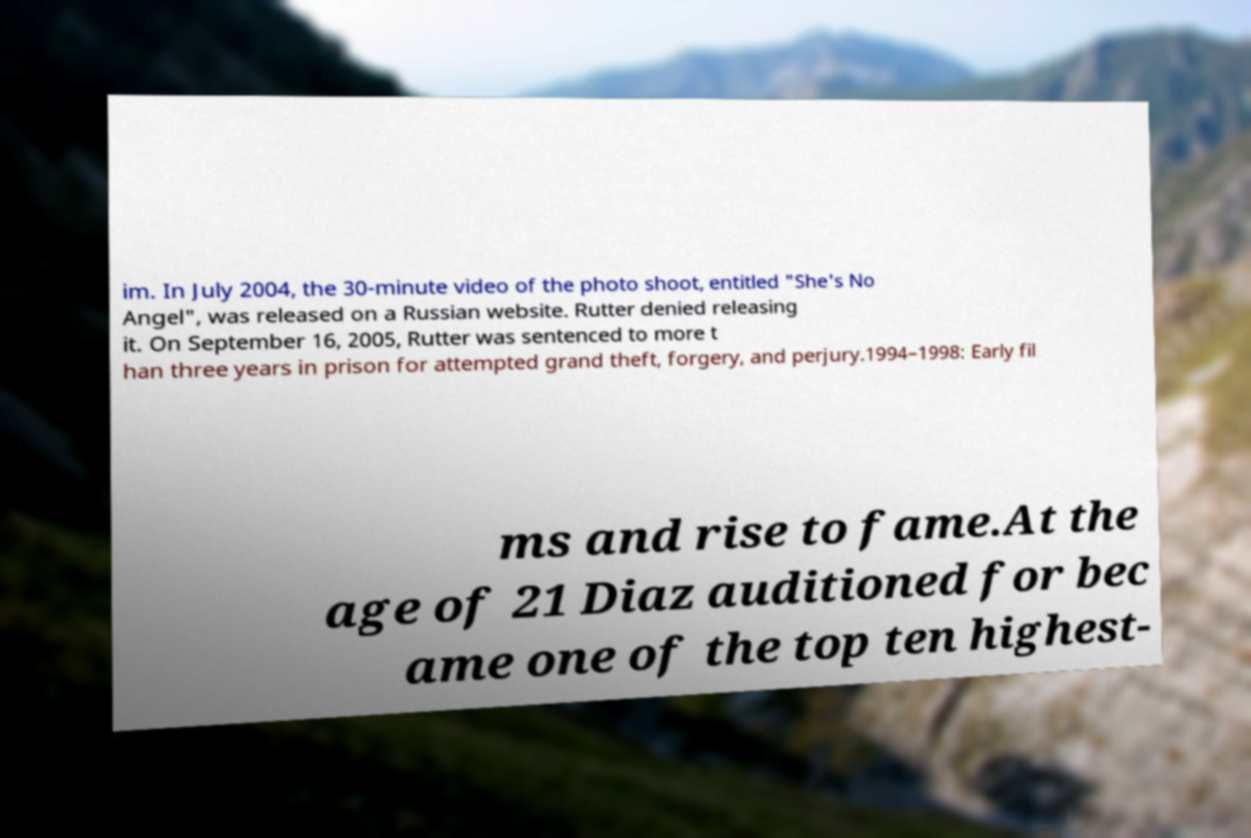Can you accurately transcribe the text from the provided image for me? im. In July 2004, the 30-minute video of the photo shoot, entitled "She's No Angel", was released on a Russian website. Rutter denied releasing it. On September 16, 2005, Rutter was sentenced to more t han three years in prison for attempted grand theft, forgery, and perjury.1994–1998: Early fil ms and rise to fame.At the age of 21 Diaz auditioned for bec ame one of the top ten highest- 